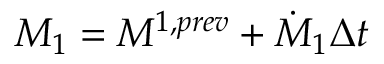Convert formula to latex. <formula><loc_0><loc_0><loc_500><loc_500>M _ { 1 } = M ^ { 1 , p r e v } + \dot { M } _ { 1 } \Delta t</formula> 